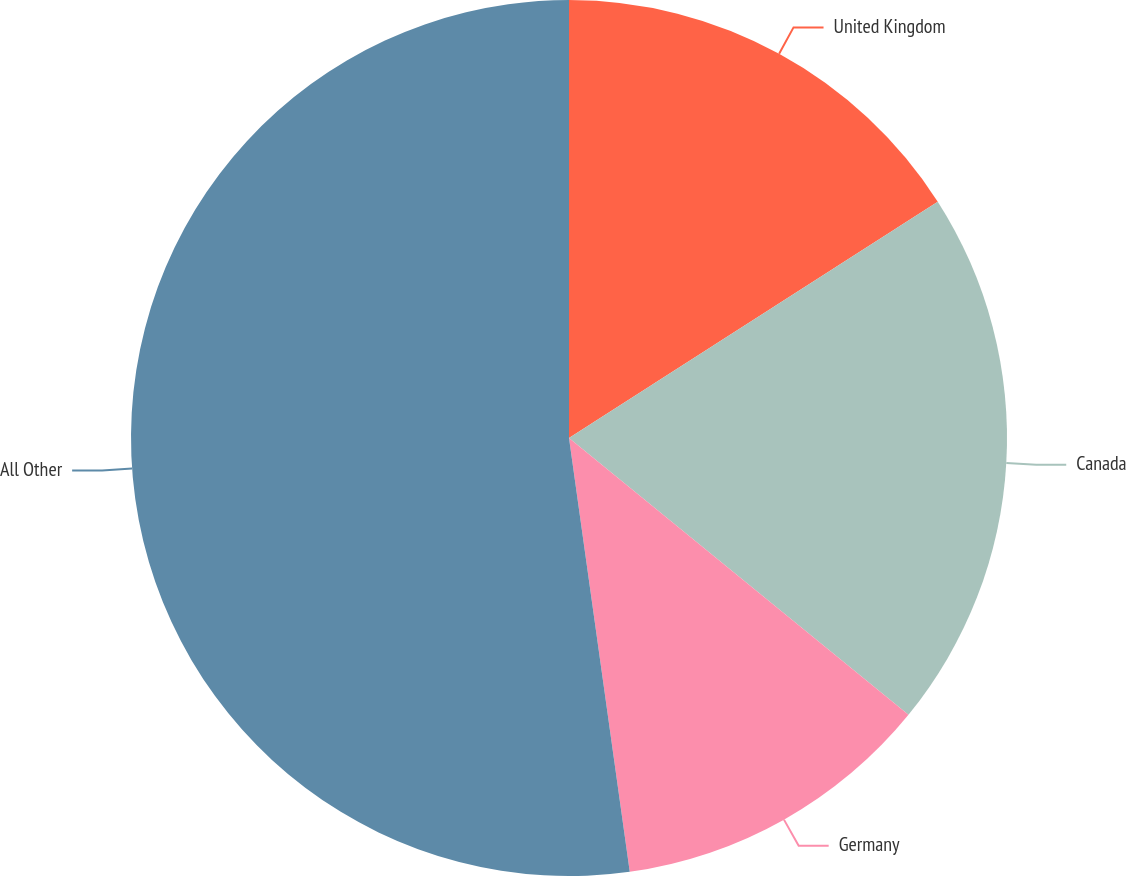<chart> <loc_0><loc_0><loc_500><loc_500><pie_chart><fcel>United Kingdom<fcel>Canada<fcel>Germany<fcel>All Other<nl><fcel>15.93%<fcel>19.96%<fcel>11.9%<fcel>52.22%<nl></chart> 